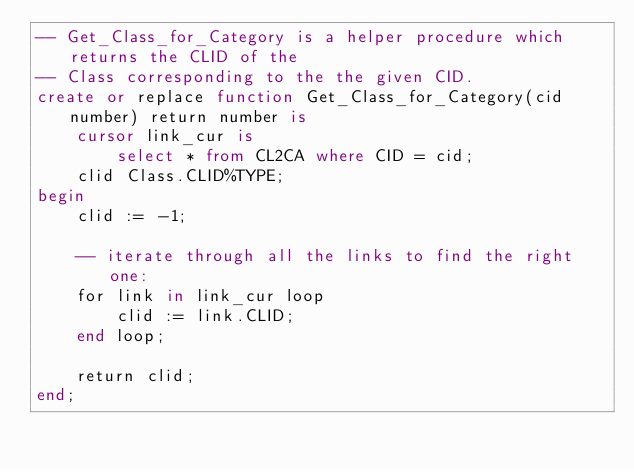<code> <loc_0><loc_0><loc_500><loc_500><_SQL_>-- Get_Class_for_Category is a helper procedure which returns the CLID of the
-- Class corresponding to the the given CID.
create or replace function Get_Class_for_Category(cid number) return number is
    cursor link_cur is
        select * from CL2CA where CID = cid;
    clid Class.CLID%TYPE;
begin
    clid := -1;

    -- iterate through all the links to find the right one:
    for link in link_cur loop
        clid := link.CLID;
    end loop;

    return clid;
end;
</code> 